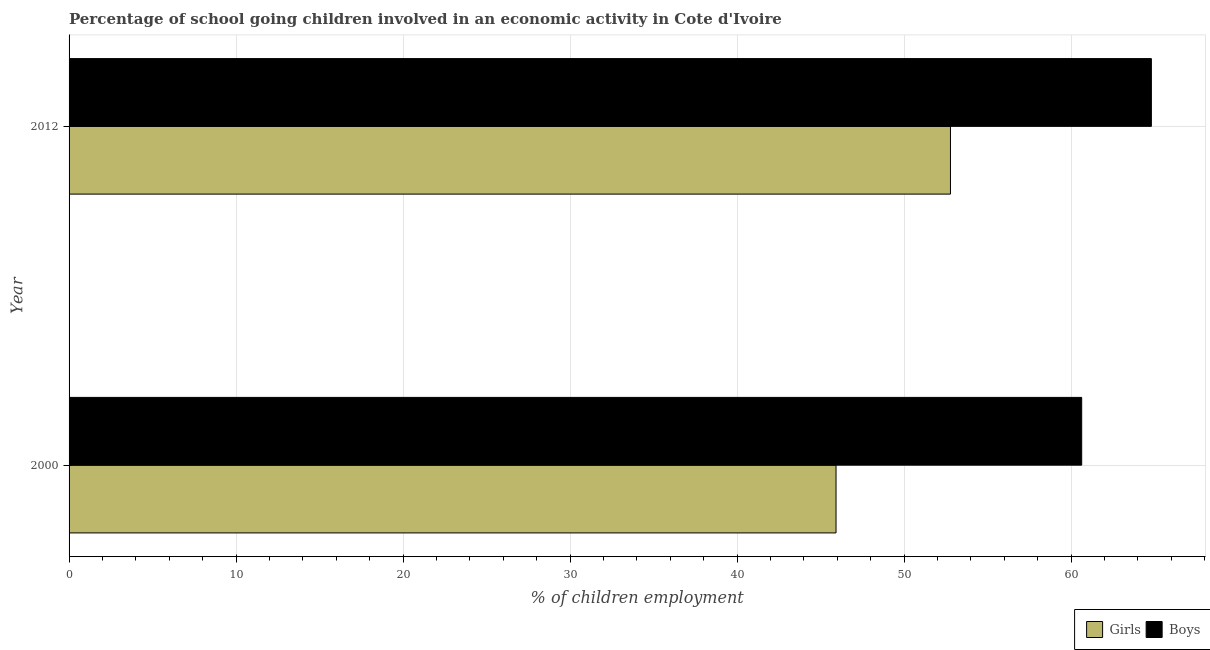How many different coloured bars are there?
Your response must be concise. 2. How many bars are there on the 2nd tick from the top?
Give a very brief answer. 2. How many bars are there on the 1st tick from the bottom?
Keep it short and to the point. 2. What is the percentage of school going boys in 2000?
Give a very brief answer. 60.64. Across all years, what is the maximum percentage of school going girls?
Offer a terse response. 52.78. Across all years, what is the minimum percentage of school going girls?
Keep it short and to the point. 45.93. In which year was the percentage of school going boys maximum?
Keep it short and to the point. 2012. What is the total percentage of school going boys in the graph?
Make the answer very short. 125.44. What is the difference between the percentage of school going boys in 2000 and that in 2012?
Give a very brief answer. -4.17. What is the difference between the percentage of school going boys in 2000 and the percentage of school going girls in 2012?
Offer a very short reply. 7.86. What is the average percentage of school going boys per year?
Provide a succinct answer. 62.72. In the year 2012, what is the difference between the percentage of school going boys and percentage of school going girls?
Make the answer very short. 12.03. What is the ratio of the percentage of school going girls in 2000 to that in 2012?
Your answer should be compact. 0.87. Is the percentage of school going girls in 2000 less than that in 2012?
Your response must be concise. Yes. Is the difference between the percentage of school going girls in 2000 and 2012 greater than the difference between the percentage of school going boys in 2000 and 2012?
Your response must be concise. No. In how many years, is the percentage of school going girls greater than the average percentage of school going girls taken over all years?
Make the answer very short. 1. What does the 2nd bar from the top in 2012 represents?
Ensure brevity in your answer.  Girls. What does the 2nd bar from the bottom in 2012 represents?
Provide a short and direct response. Boys. How many bars are there?
Offer a terse response. 4. Are all the bars in the graph horizontal?
Offer a very short reply. Yes. How many years are there in the graph?
Your response must be concise. 2. What is the difference between two consecutive major ticks on the X-axis?
Your answer should be very brief. 10. Does the graph contain any zero values?
Your answer should be very brief. No. How many legend labels are there?
Keep it short and to the point. 2. What is the title of the graph?
Provide a succinct answer. Percentage of school going children involved in an economic activity in Cote d'Ivoire. Does "Primary school" appear as one of the legend labels in the graph?
Your answer should be very brief. No. What is the label or title of the X-axis?
Make the answer very short. % of children employment. What is the % of children employment in Girls in 2000?
Provide a short and direct response. 45.93. What is the % of children employment in Boys in 2000?
Provide a succinct answer. 60.64. What is the % of children employment of Girls in 2012?
Keep it short and to the point. 52.78. What is the % of children employment in Boys in 2012?
Your answer should be very brief. 64.81. Across all years, what is the maximum % of children employment in Girls?
Provide a succinct answer. 52.78. Across all years, what is the maximum % of children employment in Boys?
Your answer should be compact. 64.81. Across all years, what is the minimum % of children employment in Girls?
Provide a short and direct response. 45.93. Across all years, what is the minimum % of children employment in Boys?
Offer a terse response. 60.64. What is the total % of children employment in Girls in the graph?
Offer a terse response. 98.7. What is the total % of children employment of Boys in the graph?
Offer a very short reply. 125.44. What is the difference between the % of children employment in Girls in 2000 and that in 2012?
Provide a succinct answer. -6.85. What is the difference between the % of children employment of Boys in 2000 and that in 2012?
Provide a short and direct response. -4.17. What is the difference between the % of children employment in Girls in 2000 and the % of children employment in Boys in 2012?
Offer a very short reply. -18.88. What is the average % of children employment in Girls per year?
Make the answer very short. 49.35. What is the average % of children employment in Boys per year?
Provide a succinct answer. 62.72. In the year 2000, what is the difference between the % of children employment in Girls and % of children employment in Boys?
Give a very brief answer. -14.71. In the year 2012, what is the difference between the % of children employment in Girls and % of children employment in Boys?
Offer a terse response. -12.03. What is the ratio of the % of children employment in Girls in 2000 to that in 2012?
Give a very brief answer. 0.87. What is the ratio of the % of children employment of Boys in 2000 to that in 2012?
Give a very brief answer. 0.94. What is the difference between the highest and the second highest % of children employment of Girls?
Keep it short and to the point. 6.85. What is the difference between the highest and the second highest % of children employment in Boys?
Your answer should be compact. 4.17. What is the difference between the highest and the lowest % of children employment in Girls?
Keep it short and to the point. 6.85. What is the difference between the highest and the lowest % of children employment in Boys?
Offer a terse response. 4.17. 